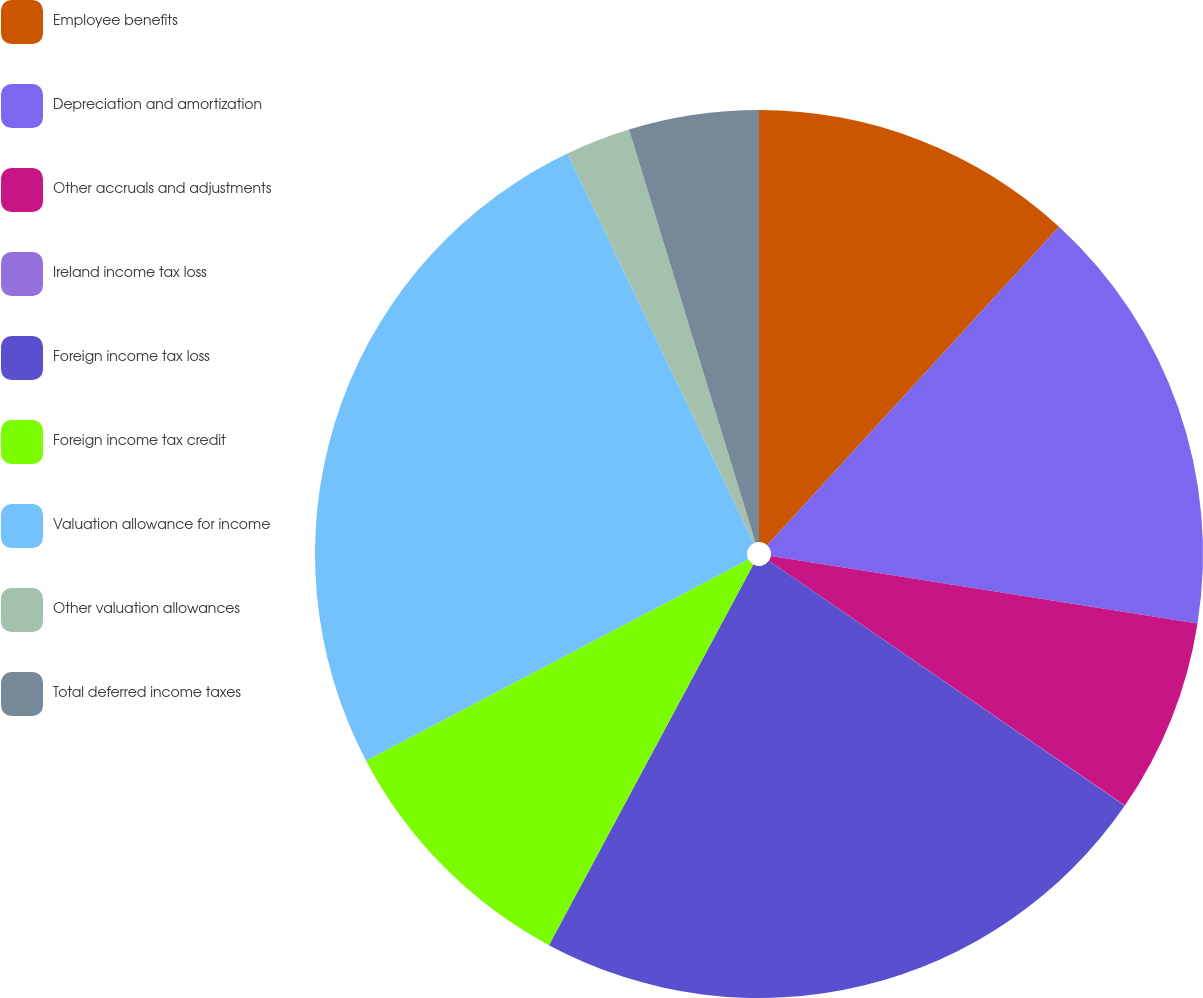Convert chart to OTSL. <chart><loc_0><loc_0><loc_500><loc_500><pie_chart><fcel>Employee benefits<fcel>Depreciation and amortization<fcel>Other accruals and adjustments<fcel>Ireland income tax loss<fcel>Foreign income tax loss<fcel>Foreign income tax credit<fcel>Valuation allowance for income<fcel>Other valuation allowances<fcel>Total deferred income taxes<nl><fcel>11.81%<fcel>15.69%<fcel>7.09%<fcel>0.01%<fcel>23.25%<fcel>9.45%<fcel>25.61%<fcel>2.37%<fcel>4.73%<nl></chart> 